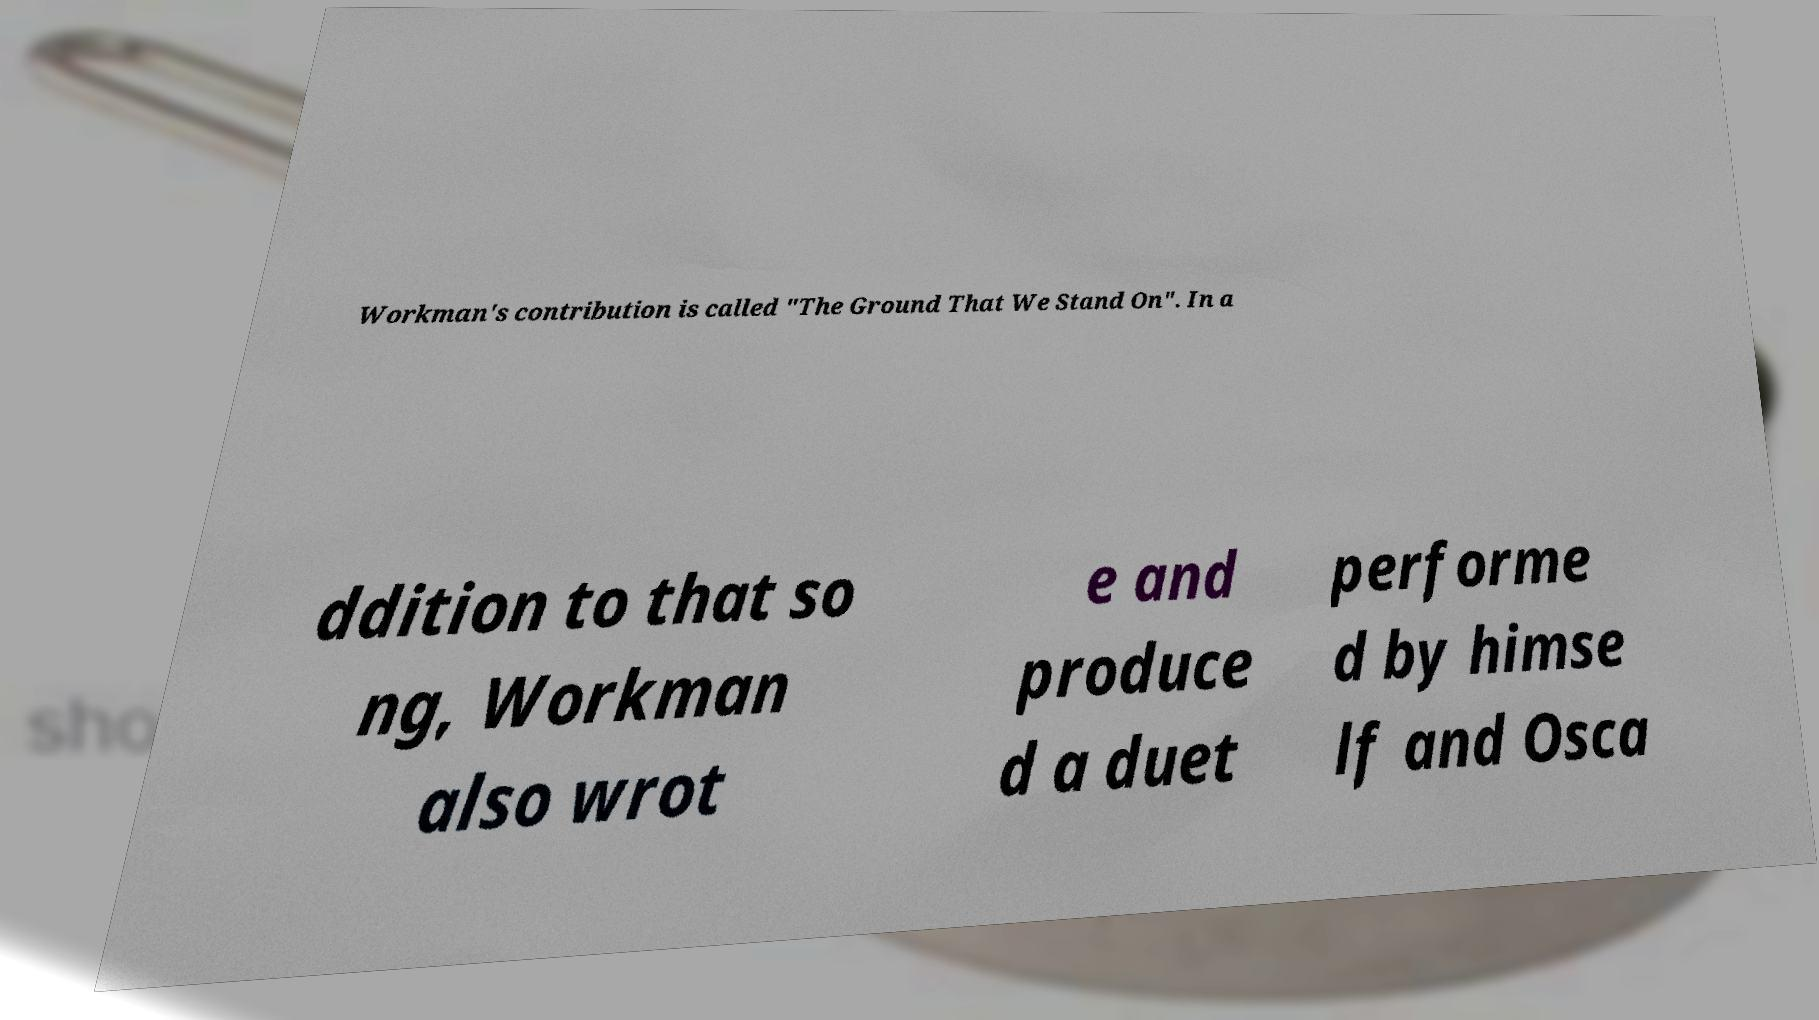Could you extract and type out the text from this image? Workman's contribution is called "The Ground That We Stand On". In a ddition to that so ng, Workman also wrot e and produce d a duet performe d by himse lf and Osca 